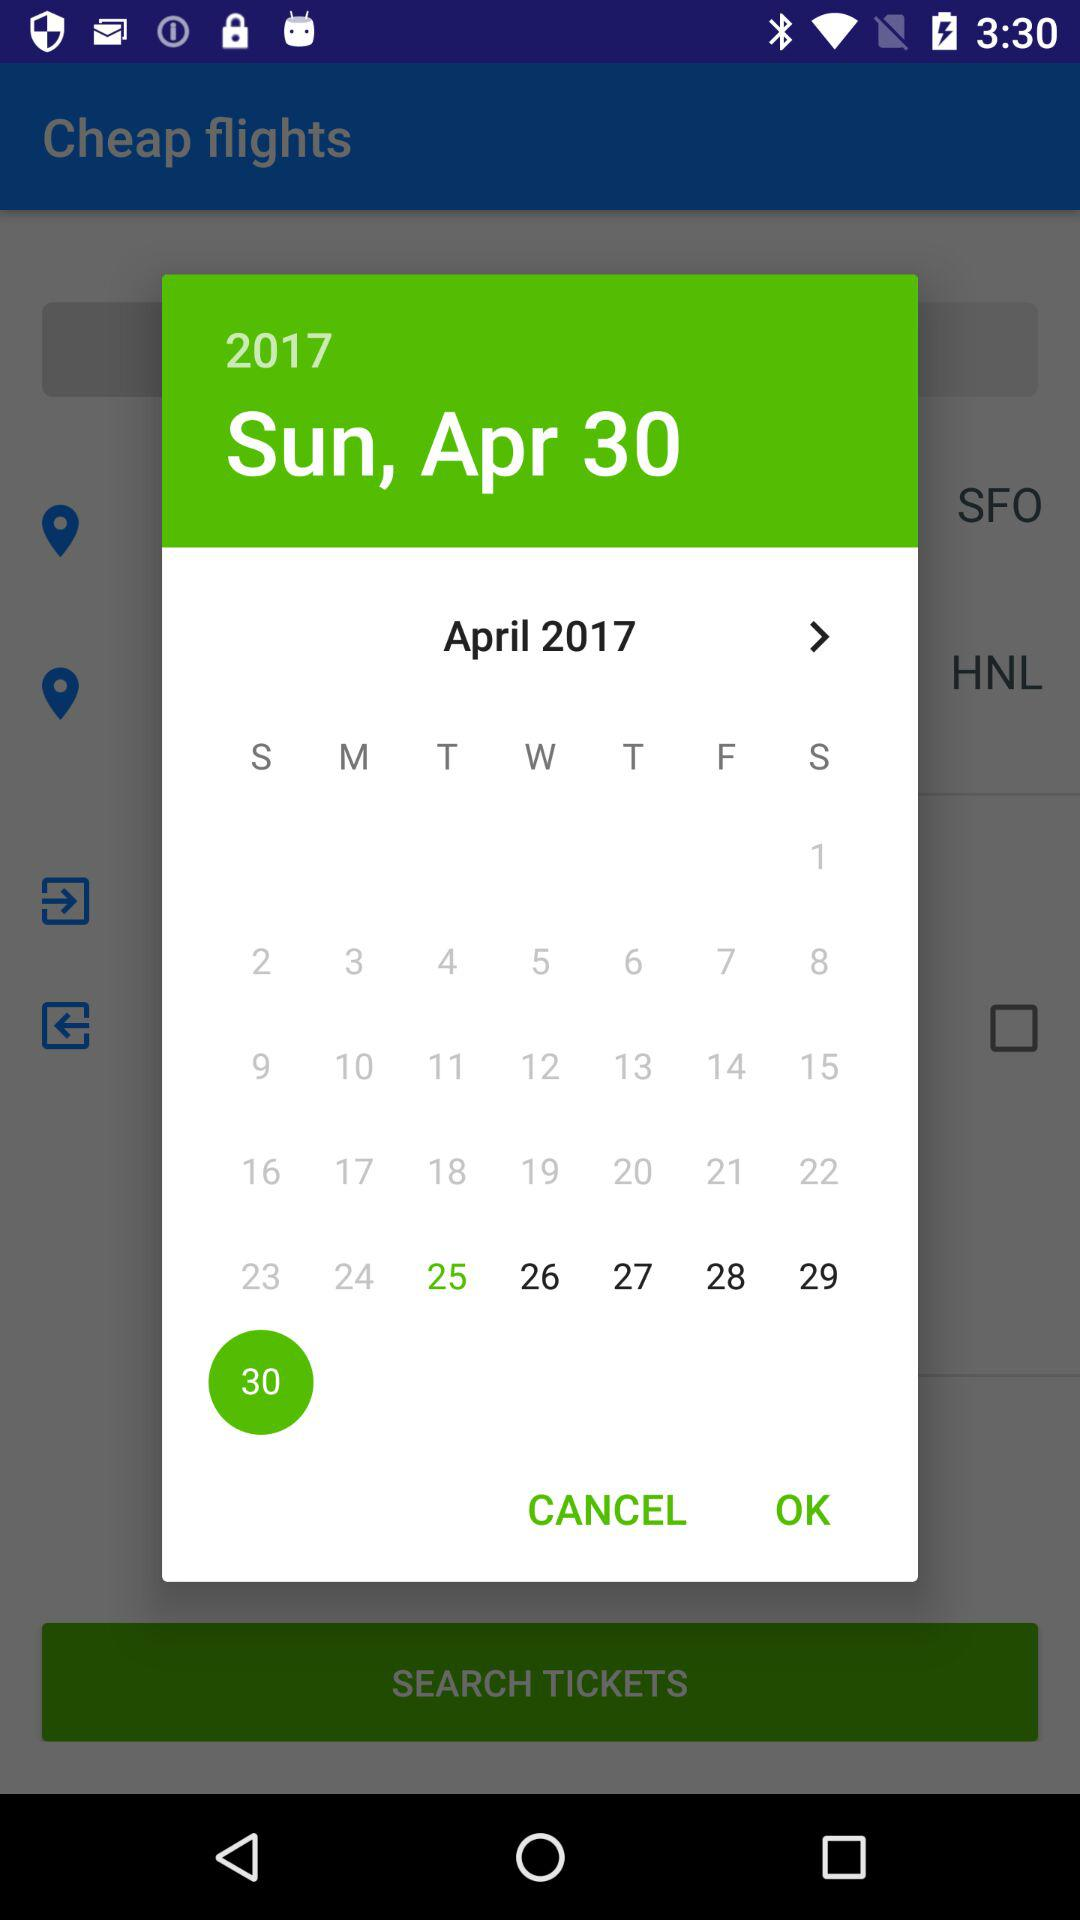Which date is selected? The selected date is Sunday, April 30, 2017. 